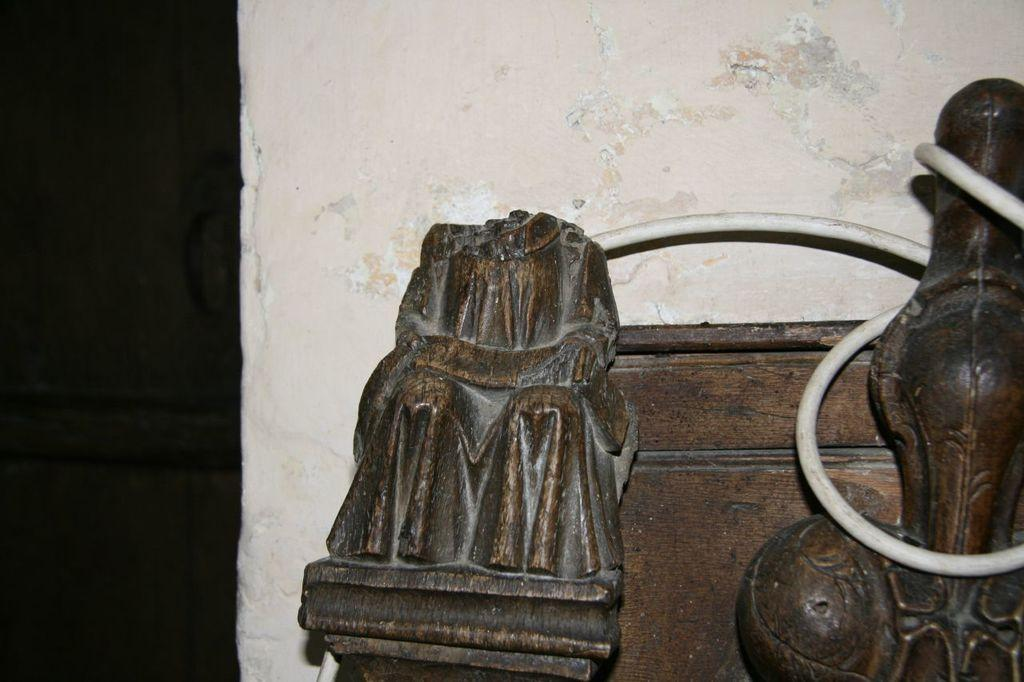What type of objects are in the front of the image? There are wooden objects in the front of the image. What can be seen in the background of the image? There is a wall in the background of the image. What type of plastic pancake is being held by the arm in the image? There is no plastic pancake or arm present in the image. 